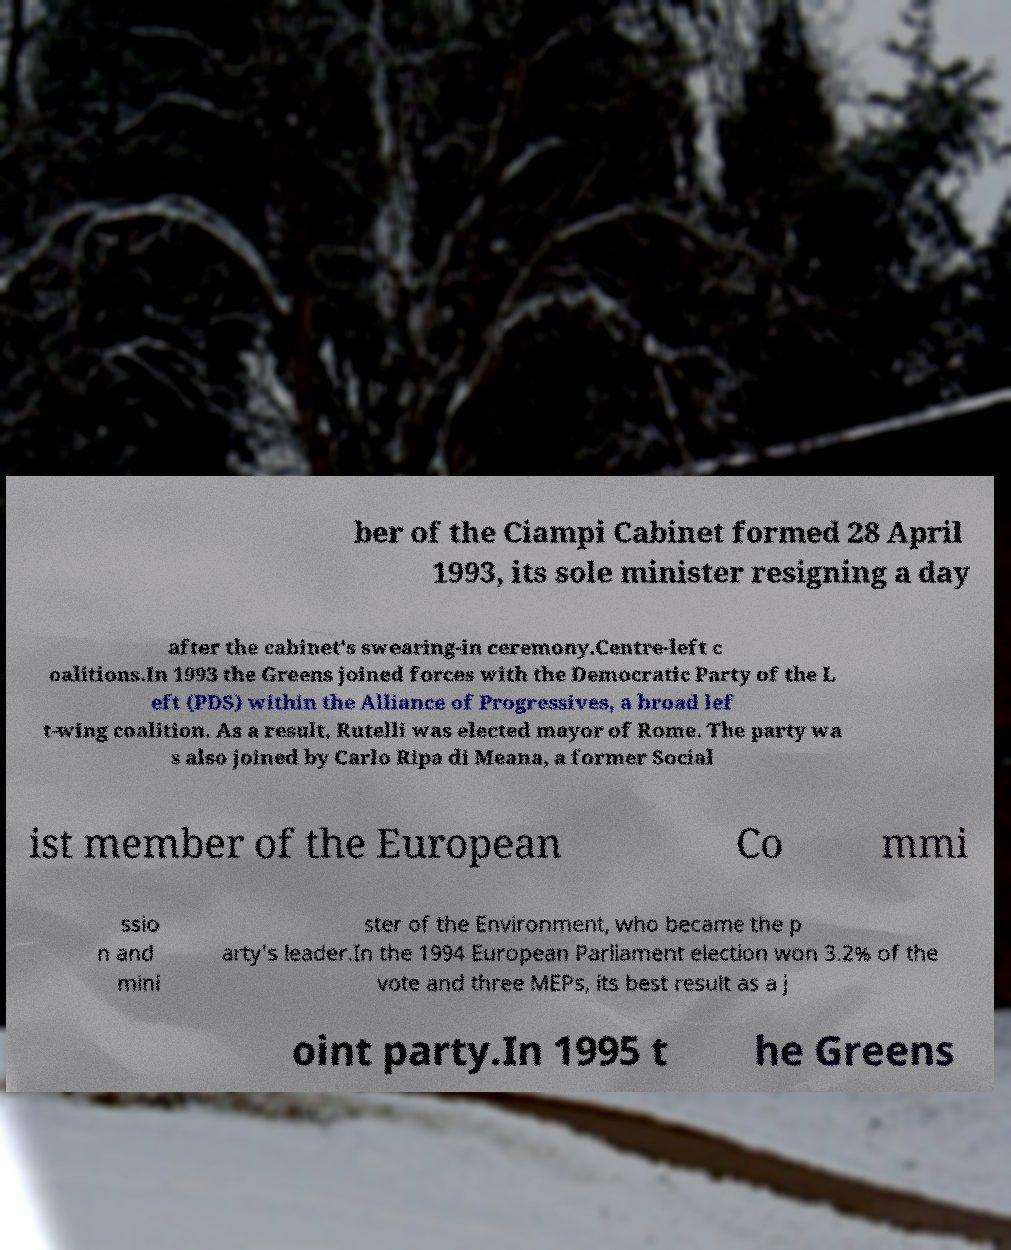Please read and relay the text visible in this image. What does it say? ber of the Ciampi Cabinet formed 28 April 1993, its sole minister resigning a day after the cabinet's swearing-in ceremony.Centre-left c oalitions.In 1993 the Greens joined forces with the Democratic Party of the L eft (PDS) within the Alliance of Progressives, a broad lef t-wing coalition. As a result, Rutelli was elected mayor of Rome. The party wa s also joined by Carlo Ripa di Meana, a former Social ist member of the European Co mmi ssio n and mini ster of the Environment, who became the p arty's leader.In the 1994 European Parliament election won 3.2% of the vote and three MEPs, its best result as a j oint party.In 1995 t he Greens 